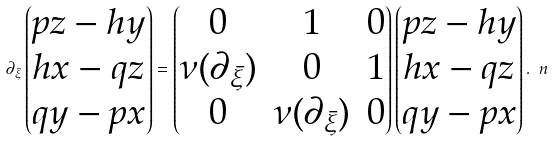<formula> <loc_0><loc_0><loc_500><loc_500>\partial _ { \bar { \xi } } \begin{pmatrix} p z - h y \\ h x - q z \\ q y - p x \end{pmatrix} = \begin{pmatrix} 0 & 1 & 0 \\ \nu ( \partial _ { \bar { \xi } } ) & 0 & 1 \\ 0 & \nu ( \partial _ { \bar { \xi } } ) & 0 \end{pmatrix} \begin{pmatrix} p z - h y \\ h x - q z \\ q y - p x \end{pmatrix} . \ n</formula> 